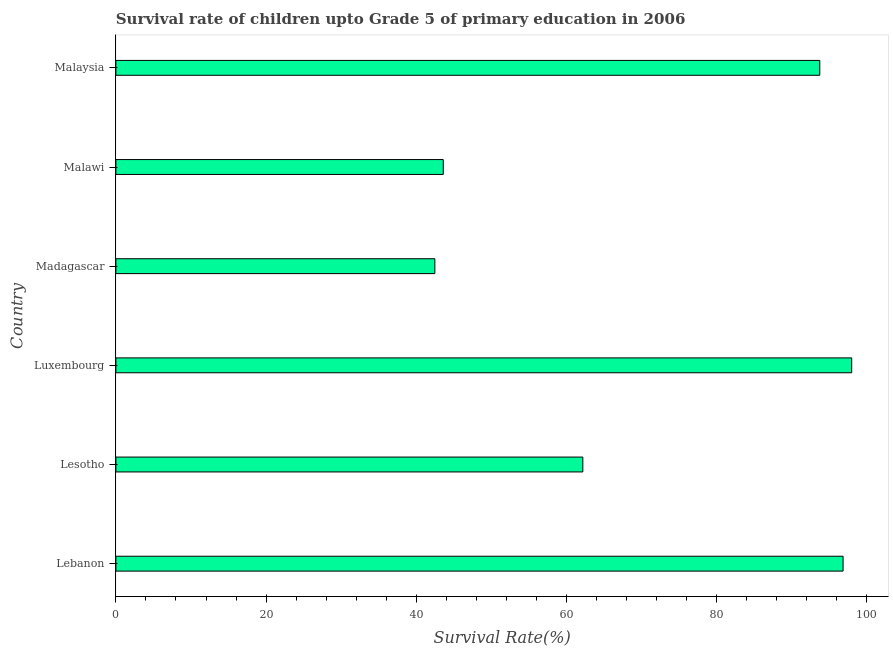Does the graph contain any zero values?
Your answer should be compact. No. Does the graph contain grids?
Provide a succinct answer. No. What is the title of the graph?
Give a very brief answer. Survival rate of children upto Grade 5 of primary education in 2006 . What is the label or title of the X-axis?
Offer a terse response. Survival Rate(%). What is the label or title of the Y-axis?
Provide a short and direct response. Country. What is the survival rate in Malawi?
Offer a very short reply. 43.59. Across all countries, what is the maximum survival rate?
Give a very brief answer. 97.97. Across all countries, what is the minimum survival rate?
Provide a succinct answer. 42.47. In which country was the survival rate maximum?
Your answer should be compact. Luxembourg. In which country was the survival rate minimum?
Your response must be concise. Madagascar. What is the sum of the survival rate?
Ensure brevity in your answer.  436.72. What is the difference between the survival rate in Luxembourg and Madagascar?
Offer a very short reply. 55.5. What is the average survival rate per country?
Provide a short and direct response. 72.79. What is the median survival rate?
Ensure brevity in your answer.  77.94. In how many countries, is the survival rate greater than 72 %?
Ensure brevity in your answer.  3. What is the ratio of the survival rate in Madagascar to that in Malawi?
Your answer should be very brief. 0.97. Is the survival rate in Lesotho less than that in Madagascar?
Keep it short and to the point. No. Is the difference between the survival rate in Malawi and Malaysia greater than the difference between any two countries?
Ensure brevity in your answer.  No. What is the difference between the highest and the second highest survival rate?
Provide a short and direct response. 1.15. Is the sum of the survival rate in Lebanon and Madagascar greater than the maximum survival rate across all countries?
Ensure brevity in your answer.  Yes. What is the difference between the highest and the lowest survival rate?
Provide a short and direct response. 55.5. In how many countries, is the survival rate greater than the average survival rate taken over all countries?
Provide a succinct answer. 3. How many bars are there?
Provide a short and direct response. 6. Are all the bars in the graph horizontal?
Provide a short and direct response. Yes. What is the difference between two consecutive major ticks on the X-axis?
Your response must be concise. 20. Are the values on the major ticks of X-axis written in scientific E-notation?
Offer a terse response. No. What is the Survival Rate(%) of Lebanon?
Provide a short and direct response. 96.82. What is the Survival Rate(%) of Lesotho?
Your response must be concise. 62.17. What is the Survival Rate(%) in Luxembourg?
Offer a terse response. 97.97. What is the Survival Rate(%) in Madagascar?
Offer a very short reply. 42.47. What is the Survival Rate(%) in Malawi?
Ensure brevity in your answer.  43.59. What is the Survival Rate(%) of Malaysia?
Keep it short and to the point. 93.72. What is the difference between the Survival Rate(%) in Lebanon and Lesotho?
Your answer should be very brief. 34.65. What is the difference between the Survival Rate(%) in Lebanon and Luxembourg?
Give a very brief answer. -1.15. What is the difference between the Survival Rate(%) in Lebanon and Madagascar?
Provide a succinct answer. 54.35. What is the difference between the Survival Rate(%) in Lebanon and Malawi?
Ensure brevity in your answer.  53.23. What is the difference between the Survival Rate(%) in Lebanon and Malaysia?
Your answer should be very brief. 3.1. What is the difference between the Survival Rate(%) in Lesotho and Luxembourg?
Provide a succinct answer. -35.8. What is the difference between the Survival Rate(%) in Lesotho and Madagascar?
Offer a very short reply. 19.7. What is the difference between the Survival Rate(%) in Lesotho and Malawi?
Make the answer very short. 18.58. What is the difference between the Survival Rate(%) in Lesotho and Malaysia?
Your answer should be very brief. -31.55. What is the difference between the Survival Rate(%) in Luxembourg and Madagascar?
Your answer should be compact. 55.5. What is the difference between the Survival Rate(%) in Luxembourg and Malawi?
Ensure brevity in your answer.  54.38. What is the difference between the Survival Rate(%) in Luxembourg and Malaysia?
Offer a very short reply. 4.25. What is the difference between the Survival Rate(%) in Madagascar and Malawi?
Make the answer very short. -1.12. What is the difference between the Survival Rate(%) in Madagascar and Malaysia?
Give a very brief answer. -51.25. What is the difference between the Survival Rate(%) in Malawi and Malaysia?
Provide a short and direct response. -50.13. What is the ratio of the Survival Rate(%) in Lebanon to that in Lesotho?
Keep it short and to the point. 1.56. What is the ratio of the Survival Rate(%) in Lebanon to that in Luxembourg?
Ensure brevity in your answer.  0.99. What is the ratio of the Survival Rate(%) in Lebanon to that in Madagascar?
Keep it short and to the point. 2.28. What is the ratio of the Survival Rate(%) in Lebanon to that in Malawi?
Give a very brief answer. 2.22. What is the ratio of the Survival Rate(%) in Lebanon to that in Malaysia?
Provide a succinct answer. 1.03. What is the ratio of the Survival Rate(%) in Lesotho to that in Luxembourg?
Ensure brevity in your answer.  0.64. What is the ratio of the Survival Rate(%) in Lesotho to that in Madagascar?
Your answer should be compact. 1.46. What is the ratio of the Survival Rate(%) in Lesotho to that in Malawi?
Offer a very short reply. 1.43. What is the ratio of the Survival Rate(%) in Lesotho to that in Malaysia?
Your answer should be very brief. 0.66. What is the ratio of the Survival Rate(%) in Luxembourg to that in Madagascar?
Your response must be concise. 2.31. What is the ratio of the Survival Rate(%) in Luxembourg to that in Malawi?
Your answer should be very brief. 2.25. What is the ratio of the Survival Rate(%) in Luxembourg to that in Malaysia?
Your answer should be very brief. 1.04. What is the ratio of the Survival Rate(%) in Madagascar to that in Malawi?
Keep it short and to the point. 0.97. What is the ratio of the Survival Rate(%) in Madagascar to that in Malaysia?
Keep it short and to the point. 0.45. What is the ratio of the Survival Rate(%) in Malawi to that in Malaysia?
Provide a succinct answer. 0.47. 